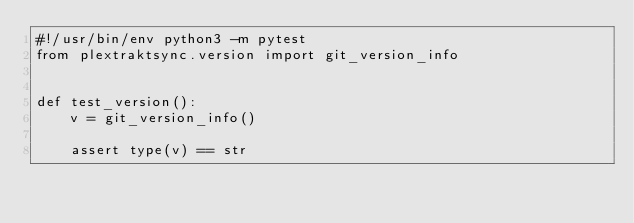<code> <loc_0><loc_0><loc_500><loc_500><_Python_>#!/usr/bin/env python3 -m pytest
from plextraktsync.version import git_version_info


def test_version():
    v = git_version_info()

    assert type(v) == str
</code> 